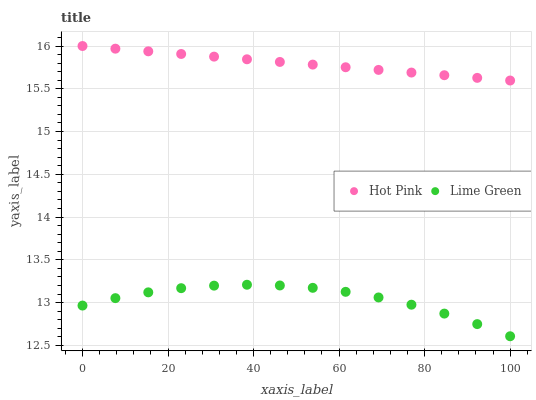Does Lime Green have the minimum area under the curve?
Answer yes or no. Yes. Does Hot Pink have the maximum area under the curve?
Answer yes or no. Yes. Does Lime Green have the maximum area under the curve?
Answer yes or no. No. Is Hot Pink the smoothest?
Answer yes or no. Yes. Is Lime Green the roughest?
Answer yes or no. Yes. Is Lime Green the smoothest?
Answer yes or no. No. Does Lime Green have the lowest value?
Answer yes or no. Yes. Does Hot Pink have the highest value?
Answer yes or no. Yes. Does Lime Green have the highest value?
Answer yes or no. No. Is Lime Green less than Hot Pink?
Answer yes or no. Yes. Is Hot Pink greater than Lime Green?
Answer yes or no. Yes. Does Lime Green intersect Hot Pink?
Answer yes or no. No. 